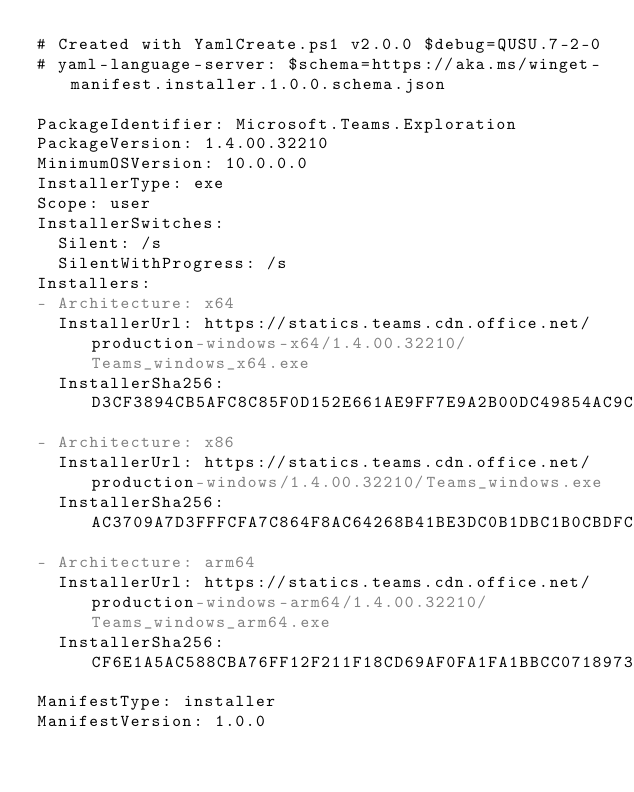Convert code to text. <code><loc_0><loc_0><loc_500><loc_500><_YAML_># Created with YamlCreate.ps1 v2.0.0 $debug=QUSU.7-2-0
# yaml-language-server: $schema=https://aka.ms/winget-manifest.installer.1.0.0.schema.json

PackageIdentifier: Microsoft.Teams.Exploration
PackageVersion: 1.4.00.32210
MinimumOSVersion: 10.0.0.0
InstallerType: exe
Scope: user
InstallerSwitches:
  Silent: /s
  SilentWithProgress: /s
Installers:
- Architecture: x64
  InstallerUrl: https://statics.teams.cdn.office.net/production-windows-x64/1.4.00.32210/Teams_windows_x64.exe
  InstallerSha256: D3CF3894CB5AFC8C85F0D152E661AE9FF7E9A2B00DC49854AC9C15FAF548937B
- Architecture: x86
  InstallerUrl: https://statics.teams.cdn.office.net/production-windows/1.4.00.32210/Teams_windows.exe
  InstallerSha256: AC3709A7D3FFFCFA7C864F8AC64268B41BE3DC0B1DBC1B0CBDFC9D6B1513EBA0
- Architecture: arm64
  InstallerUrl: https://statics.teams.cdn.office.net/production-windows-arm64/1.4.00.32210/Teams_windows_arm64.exe
  InstallerSha256: CF6E1A5AC588CBA76FF12F211F18CD69AF0FA1FA1BBCC0718973A3270105AE1E
ManifestType: installer
ManifestVersion: 1.0.0
</code> 